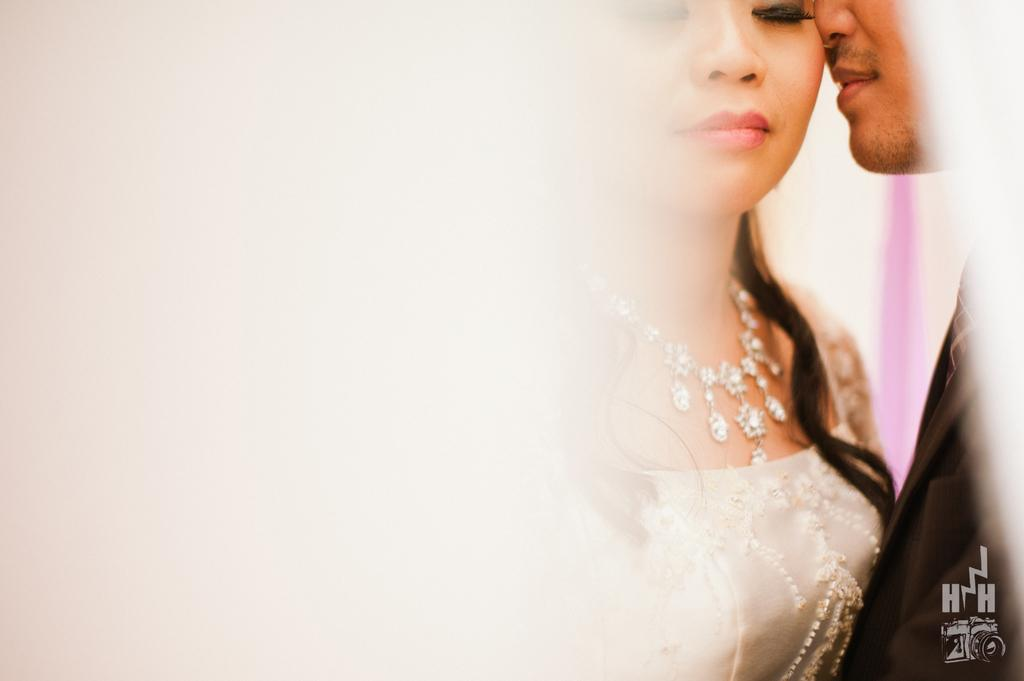How many people are present in the image? There is a woman and a man in the image. What are the woman and the man doing in the image? The woman and the man are standing. What can be observed about the image itself? The image appears to be edited, and there is a watermark on it. What type of prison can be seen in the background of the image? There is no prison present in the image; it only features a woman and a man standing. Can you tell me how the guide is helping the woman and the man in the image? There is no guide present in the image, as it only features a woman and a man standing. 